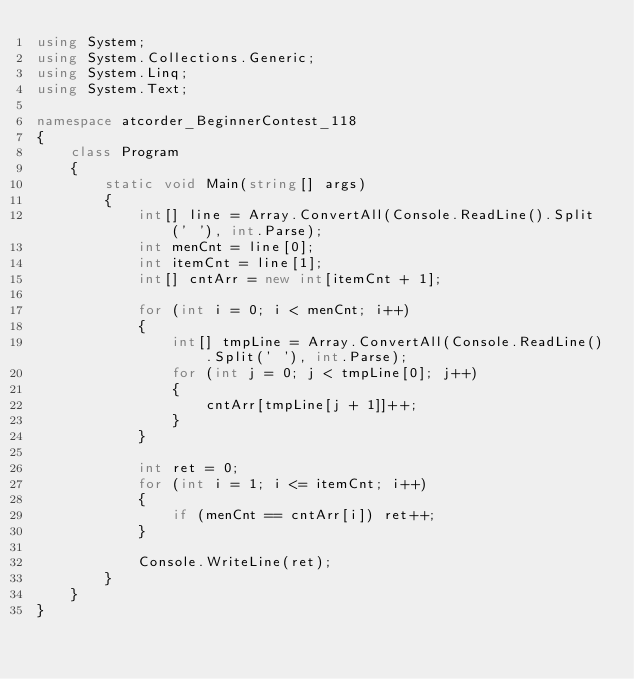Convert code to text. <code><loc_0><loc_0><loc_500><loc_500><_C#_>using System;
using System.Collections.Generic;
using System.Linq;
using System.Text;

namespace atcorder_BeginnerContest_118
{
    class Program
    {
        static void Main(string[] args)
        {
            int[] line = Array.ConvertAll(Console.ReadLine().Split(' '), int.Parse);
            int menCnt = line[0];
            int itemCnt = line[1];
            int[] cntArr = new int[itemCnt + 1];

            for (int i = 0; i < menCnt; i++)
            {
                int[] tmpLine = Array.ConvertAll(Console.ReadLine().Split(' '), int.Parse);
                for (int j = 0; j < tmpLine[0]; j++)
                {
                    cntArr[tmpLine[j + 1]]++;
                }
            }

            int ret = 0;
            for (int i = 1; i <= itemCnt; i++)
            {
                if (menCnt == cntArr[i]) ret++;
            }

            Console.WriteLine(ret);
        }
    }
}
</code> 